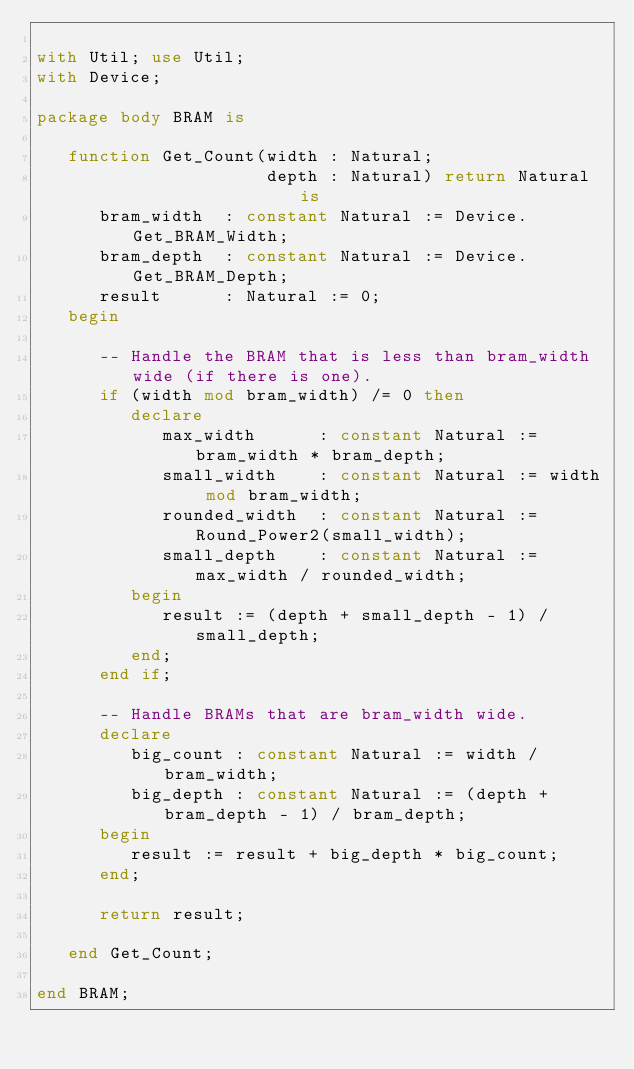Convert code to text. <code><loc_0><loc_0><loc_500><loc_500><_Ada_>
with Util; use Util;
with Device;

package body BRAM is

   function Get_Count(width : Natural;
                      depth : Natural) return Natural is
      bram_width  : constant Natural := Device.Get_BRAM_Width;
      bram_depth  : constant Natural := Device.Get_BRAM_Depth;
      result      : Natural := 0;
   begin

      -- Handle the BRAM that is less than bram_width wide (if there is one).
      if (width mod bram_width) /= 0 then
         declare
            max_width      : constant Natural := bram_width * bram_depth;
            small_width    : constant Natural := width mod bram_width;
            rounded_width  : constant Natural := Round_Power2(small_width);
            small_depth    : constant Natural := max_width / rounded_width;
         begin
            result := (depth + small_depth - 1) / small_depth;
         end;
      end if;

      -- Handle BRAMs that are bram_width wide.
      declare
         big_count : constant Natural := width / bram_width;
         big_depth : constant Natural := (depth + bram_depth - 1) / bram_depth;
      begin
         result := result + big_depth * big_count;
      end;

      return result;

   end Get_Count;

end BRAM;
</code> 